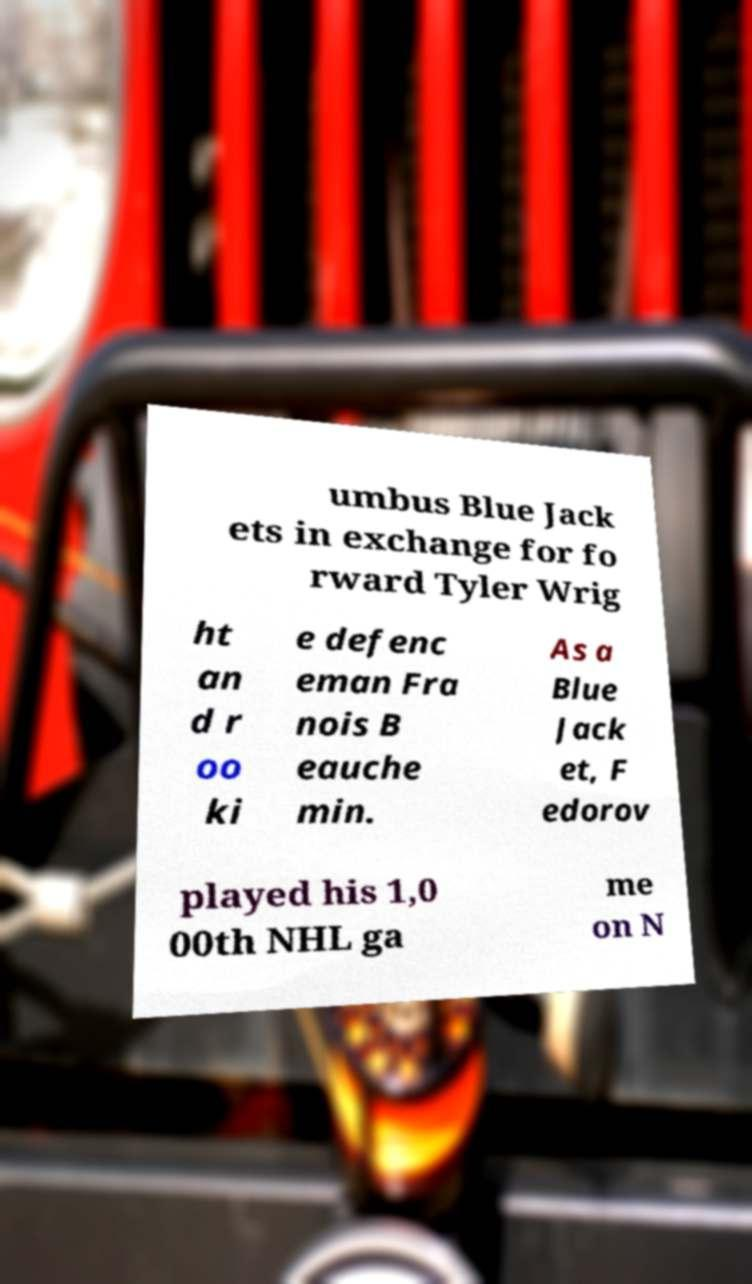Please read and relay the text visible in this image. What does it say? umbus Blue Jack ets in exchange for fo rward Tyler Wrig ht an d r oo ki e defenc eman Fra nois B eauche min. As a Blue Jack et, F edorov played his 1,0 00th NHL ga me on N 